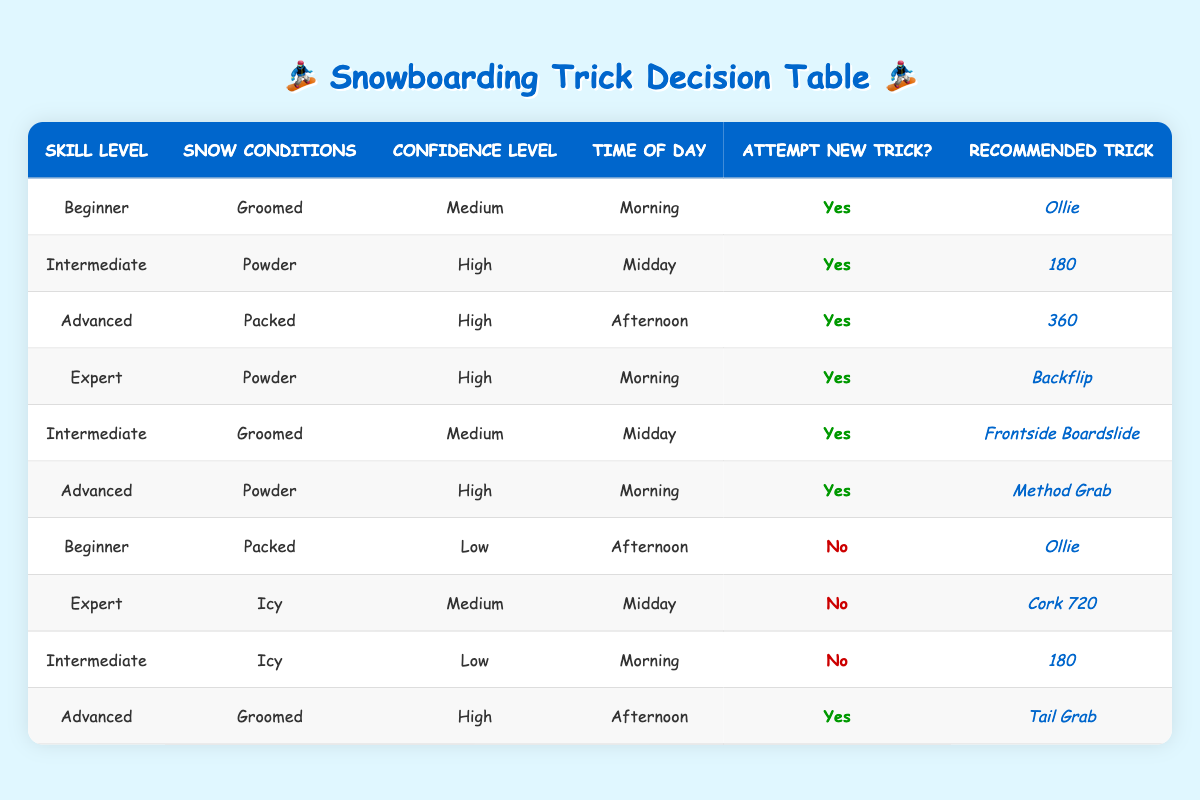What's the recommended trick for an Intermediate skill level in Powder conditions at Midday? Looking at the table, there is a specific rule that applies for "Intermediate" skill level, "Powder" conditions, and "Midday" time which states to attempt a new trick: "Yes" with the recommended trick being "180."
Answer: 180 Are Beginners advised to attempt a new trick in Packed conditions at Afternoon? According to the table, for "Beginner" skill level in "Packed" conditions at "Afternoon" with "Low" confidence, it is recommended "No" for attempting a new trick, meaning it's not advisable for them to try.
Answer: No How many tricks can Advanced snowboarders attempt in Groomed conditions? From the table, we see one row for "Advanced" in "Groomed" conditions which includes "Tail Grab." Therefore, the total count for tricks available for "Advanced" snowboarders in Groomed conditions is one.
Answer: 1 What is the most common time of day for attempting a new trick based on the data? After reviewing the table, the times of day are Morning, Midday, and Afternoon. There are entries across these three time slots, but Morning appears three times with successful attempts (2 for Advanced and 1 for Expert), while Midday has two successful attempts, and Afternoon has two. Thus, the most recommended time for attempting new tricks is Morning.
Answer: Morning Is it recommended for an Expert in Icy conditions at Midday to attempt a new trick? The table clearly shows that for "Expert" skill level in "Icy" conditions at "Midday," the decision made is "No," indicating that it’s not recommended for them to attempt a new trick.
Answer: No What is the total number of recommended tricks for Advanced snowboarders? By counting the occurrences for "Advanced" skill level in the table, there are three unique tricks recommended: "360" in Packed conditions at Afternoon, "Method Grab" in Powder at Morning, and "Tail Grab" in Groomed at Afternoon. Hence, the total number is three different tricks.
Answer: 3 Are Intermediate snowboarders always able to attempt a new trick? When analyzing the data, we see that Intermediate skill level attempted new tricks in two rows with conditions of Powder at Midday and Groomed at Midday; however, there is another row where they are not recommended to attempt a trick under Icy conditions at Morning. Therefore, it cannot be said they can always attempt a new trick.
Answer: No What trick should an Advanced snowboarder try at Afternoon in Groomed conditions? The table shows one recommendation for "Advanced" skill level in "Groomed" conditions during the "Afternoon" time: it is "Tail Grab" which is explicitly listed in the table.
Answer: Tail Grab What confidence level is required to attempt a trick as an Advanced snowboarder in Afternoon conditions? The relevant entry for "Advanced" snowboarders in "Afternoon" appears in the “Groomed” conditions with a "High" confidence level. Therefore, a High confidence level is required for them to attempt a trick in these conditions.
Answer: High 